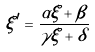Convert formula to latex. <formula><loc_0><loc_0><loc_500><loc_500>\xi ^ { \prime } = { \frac { \alpha \xi + \beta } { \gamma \xi + \delta } }</formula> 